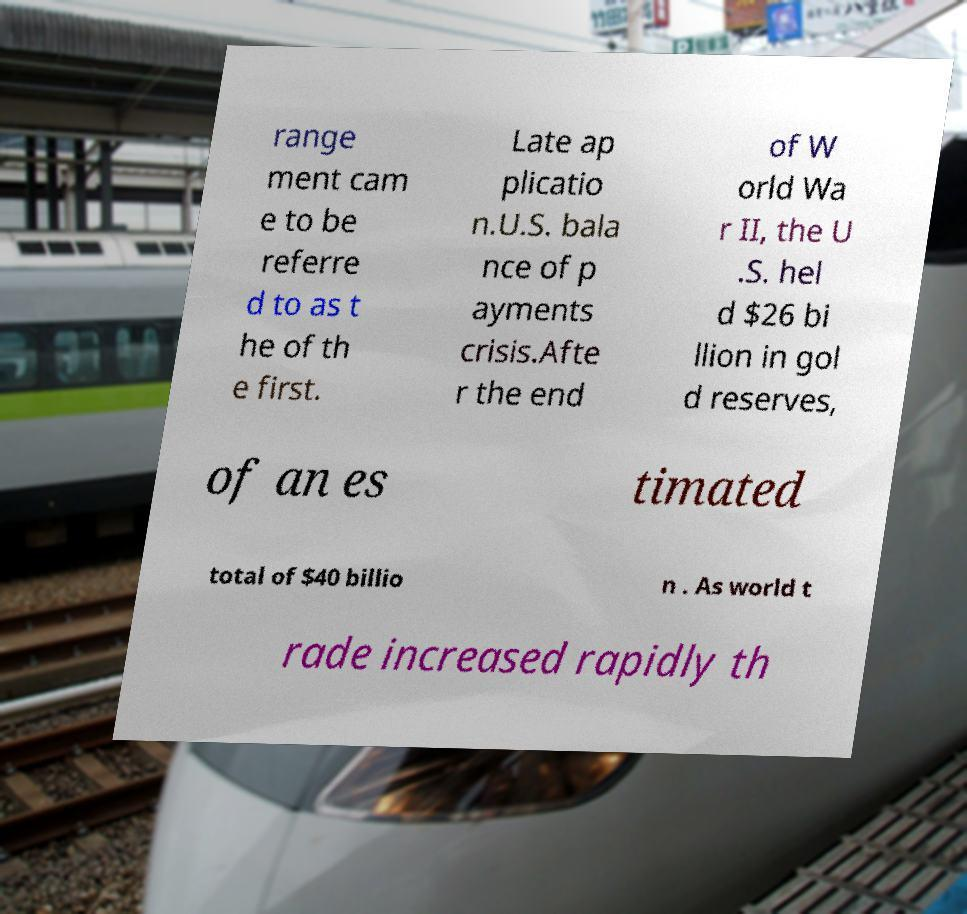There's text embedded in this image that I need extracted. Can you transcribe it verbatim? range ment cam e to be referre d to as t he of th e first. Late ap plicatio n.U.S. bala nce of p ayments crisis.Afte r the end of W orld Wa r II, the U .S. hel d $26 bi llion in gol d reserves, of an es timated total of $40 billio n . As world t rade increased rapidly th 